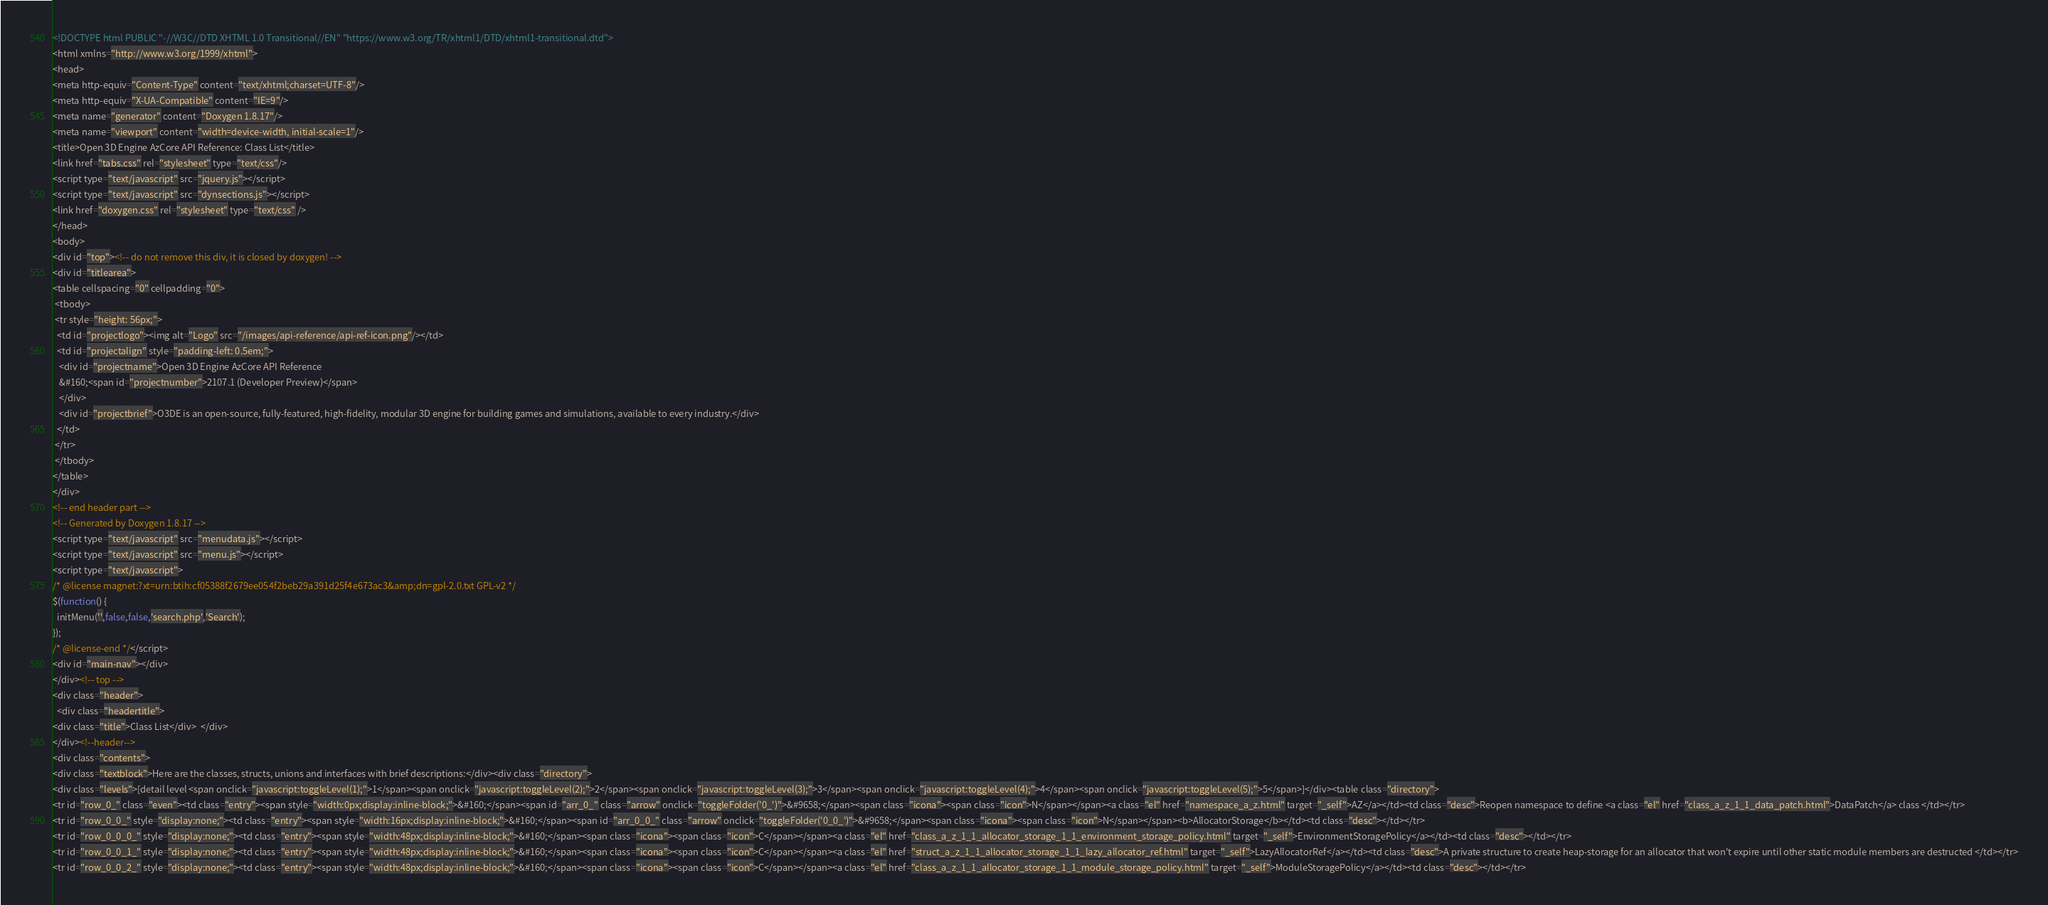<code> <loc_0><loc_0><loc_500><loc_500><_HTML_><!DOCTYPE html PUBLIC "-//W3C//DTD XHTML 1.0 Transitional//EN" "https://www.w3.org/TR/xhtml1/DTD/xhtml1-transitional.dtd">
<html xmlns="http://www.w3.org/1999/xhtml">
<head>
<meta http-equiv="Content-Type" content="text/xhtml;charset=UTF-8"/>
<meta http-equiv="X-UA-Compatible" content="IE=9"/>
<meta name="generator" content="Doxygen 1.8.17"/>
<meta name="viewport" content="width=device-width, initial-scale=1"/>
<title>Open 3D Engine AzCore API Reference: Class List</title>
<link href="tabs.css" rel="stylesheet" type="text/css"/>
<script type="text/javascript" src="jquery.js"></script>
<script type="text/javascript" src="dynsections.js"></script>
<link href="doxygen.css" rel="stylesheet" type="text/css" />
</head>
<body>
<div id="top"><!-- do not remove this div, it is closed by doxygen! -->
<div id="titlearea">
<table cellspacing="0" cellpadding="0">
 <tbody>
 <tr style="height: 56px;">
  <td id="projectlogo"><img alt="Logo" src="/images/api-reference/api-ref-icon.png"/></td>
  <td id="projectalign" style="padding-left: 0.5em;">
   <div id="projectname">Open 3D Engine AzCore API Reference
   &#160;<span id="projectnumber">2107.1 (Developer Preview)</span>
   </div>
   <div id="projectbrief">O3DE is an open-source, fully-featured, high-fidelity, modular 3D engine for building games and simulations, available to every industry.</div>
  </td>
 </tr>
 </tbody>
</table>
</div>
<!-- end header part -->
<!-- Generated by Doxygen 1.8.17 -->
<script type="text/javascript" src="menudata.js"></script>
<script type="text/javascript" src="menu.js"></script>
<script type="text/javascript">
/* @license magnet:?xt=urn:btih:cf05388f2679ee054f2beb29a391d25f4e673ac3&amp;dn=gpl-2.0.txt GPL-v2 */
$(function() {
  initMenu('',false,false,'search.php','Search');
});
/* @license-end */</script>
<div id="main-nav"></div>
</div><!-- top -->
<div class="header">
  <div class="headertitle">
<div class="title">Class List</div>  </div>
</div><!--header-->
<div class="contents">
<div class="textblock">Here are the classes, structs, unions and interfaces with brief descriptions:</div><div class="directory">
<div class="levels">[detail level <span onclick="javascript:toggleLevel(1);">1</span><span onclick="javascript:toggleLevel(2);">2</span><span onclick="javascript:toggleLevel(3);">3</span><span onclick="javascript:toggleLevel(4);">4</span><span onclick="javascript:toggleLevel(5);">5</span>]</div><table class="directory">
<tr id="row_0_" class="even"><td class="entry"><span style="width:0px;display:inline-block;">&#160;</span><span id="arr_0_" class="arrow" onclick="toggleFolder('0_')">&#9658;</span><span class="icona"><span class="icon">N</span></span><a class="el" href="namespace_a_z.html" target="_self">AZ</a></td><td class="desc">Reopen namespace to define <a class="el" href="class_a_z_1_1_data_patch.html">DataPatch</a> class </td></tr>
<tr id="row_0_0_" style="display:none;"><td class="entry"><span style="width:16px;display:inline-block;">&#160;</span><span id="arr_0_0_" class="arrow" onclick="toggleFolder('0_0_')">&#9658;</span><span class="icona"><span class="icon">N</span></span><b>AllocatorStorage</b></td><td class="desc"></td></tr>
<tr id="row_0_0_0_" style="display:none;"><td class="entry"><span style="width:48px;display:inline-block;">&#160;</span><span class="icona"><span class="icon">C</span></span><a class="el" href="class_a_z_1_1_allocator_storage_1_1_environment_storage_policy.html" target="_self">EnvironmentStoragePolicy</a></td><td class="desc"></td></tr>
<tr id="row_0_0_1_" style="display:none;"><td class="entry"><span style="width:48px;display:inline-block;">&#160;</span><span class="icona"><span class="icon">C</span></span><a class="el" href="struct_a_z_1_1_allocator_storage_1_1_lazy_allocator_ref.html" target="_self">LazyAllocatorRef</a></td><td class="desc">A private structure to create heap-storage for an allocator that won't expire until other static module members are destructed </td></tr>
<tr id="row_0_0_2_" style="display:none;"><td class="entry"><span style="width:48px;display:inline-block;">&#160;</span><span class="icona"><span class="icon">C</span></span><a class="el" href="class_a_z_1_1_allocator_storage_1_1_module_storage_policy.html" target="_self">ModuleStoragePolicy</a></td><td class="desc"></td></tr></code> 